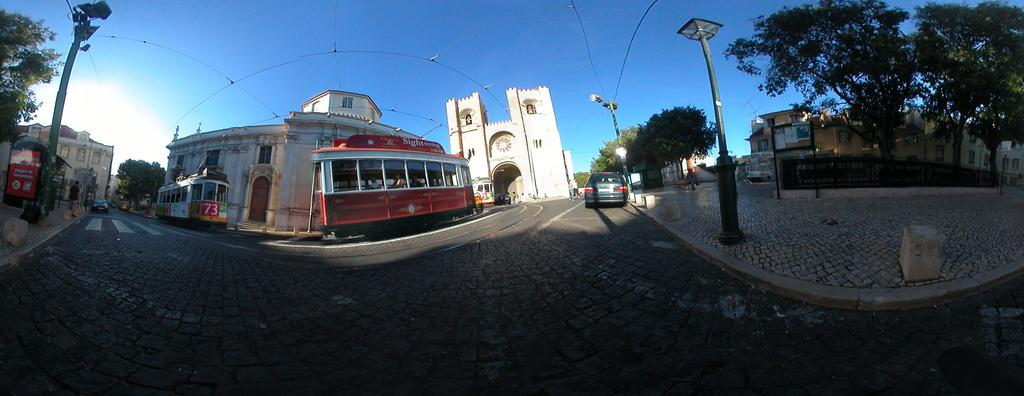What types of vehicles can be seen on the road in the image? There are cars and buses on the road in the image. What type of structures are visible in the image? There are buildings with windows in the image. What is the purpose of the pole in the image? The pole in the image is likely a utility pole or a street light pole. What other objects can be seen in the image? There are street lights, trees, a board, and a fence in the image. What is visible in the sky in the image? The sky is visible in the image. What type of committee is meeting in the image? There is no committee meeting in the image; it features vehicles, buildings, and other urban elements. Can you see any bananas hanging from the trees in the image? There are no bananas visible in the image; only trees are present. 